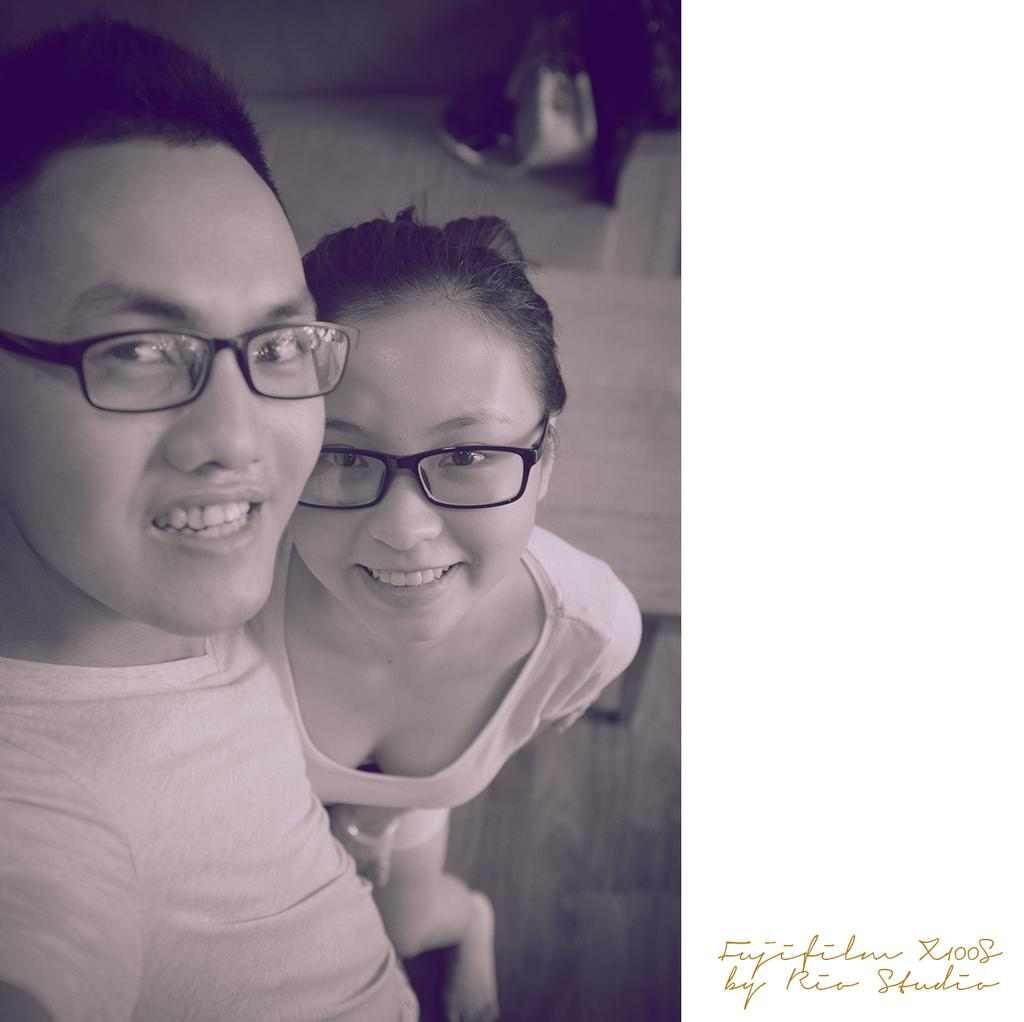What is the color scheme of the image? The image is black and white. How many people are in the image? There are two persons in the image. Can you describe the gender of the persons in the image? One of the persons is a man, and the other person is a woman. What type of wine is the fireman holding in the image? There is no fireman or wine present in the image. Can you tell me the value of the stamp on the woman's forehead in the image? There is no stamp on the woman's forehead in the image. 